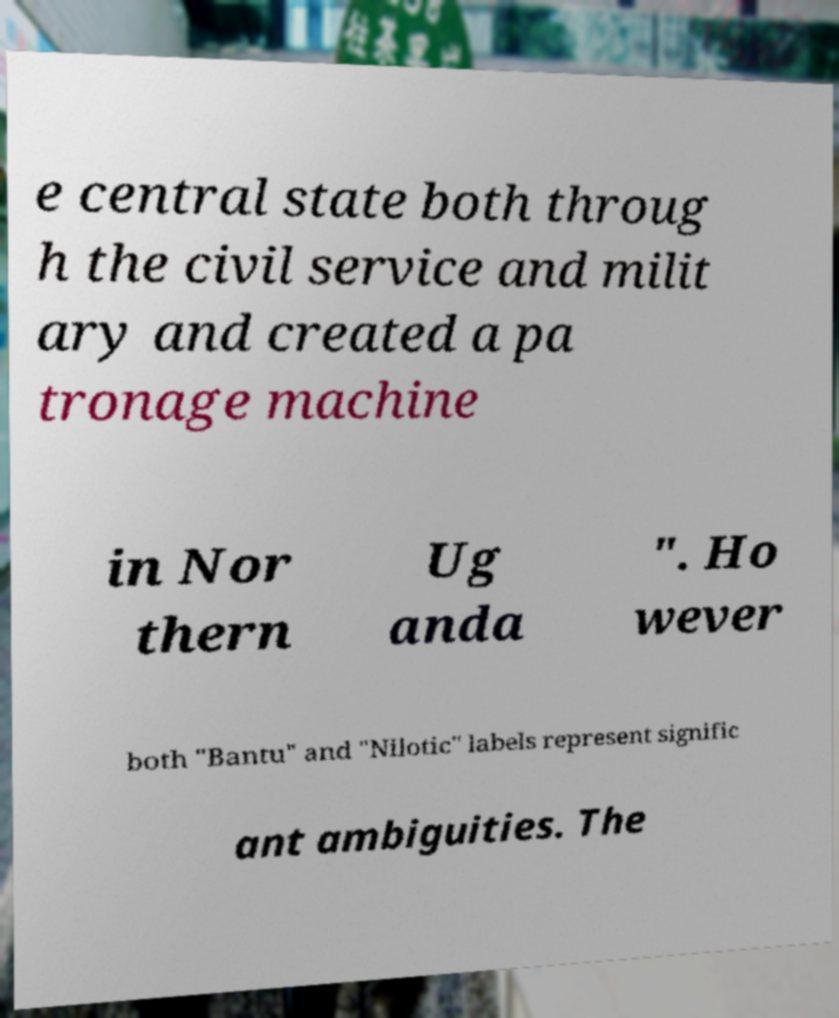Please identify and transcribe the text found in this image. e central state both throug h the civil service and milit ary and created a pa tronage machine in Nor thern Ug anda ". Ho wever both "Bantu" and "Nilotic" labels represent signific ant ambiguities. The 